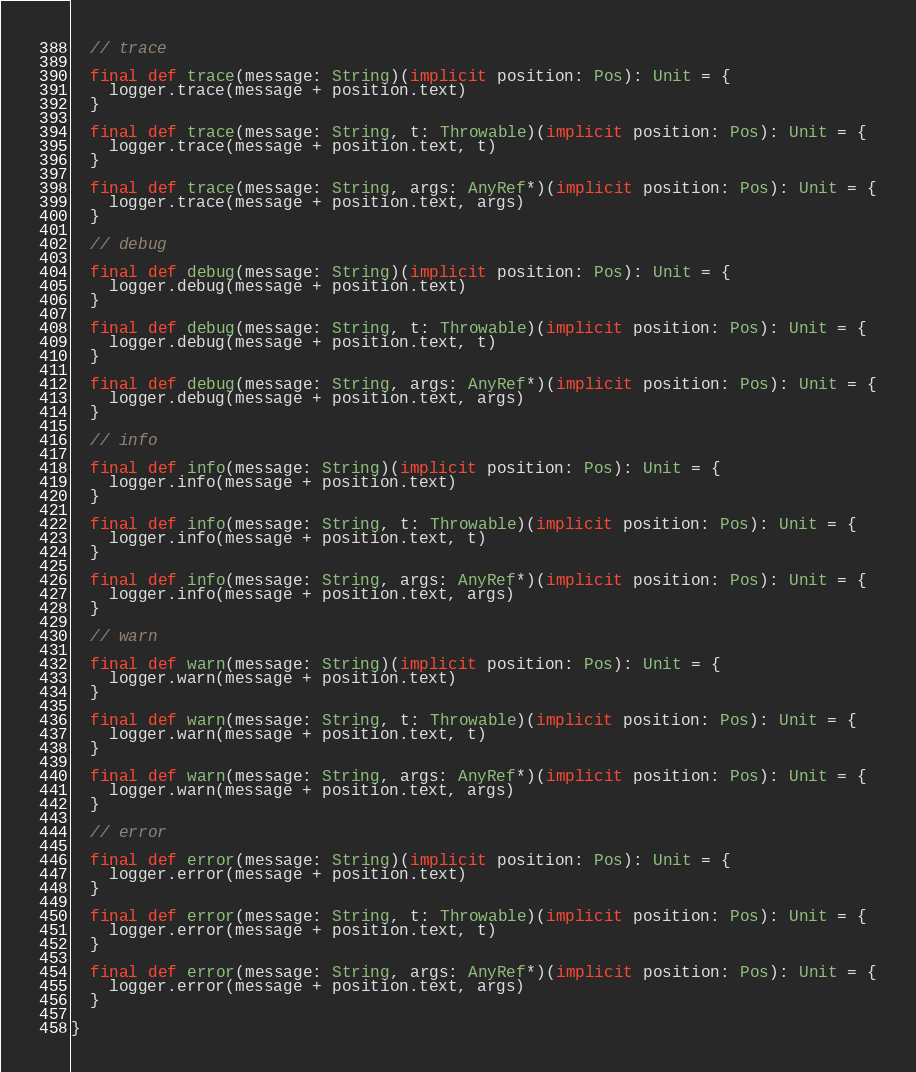<code> <loc_0><loc_0><loc_500><loc_500><_Scala_>  // trace

  final def trace(message: String)(implicit position: Pos): Unit = {
    logger.trace(message + position.text)
  }

  final def trace(message: String, t: Throwable)(implicit position: Pos): Unit = {
    logger.trace(message + position.text, t)
  }

  final def trace(message: String, args: AnyRef*)(implicit position: Pos): Unit = {
    logger.trace(message + position.text, args)
  }

  // debug

  final def debug(message: String)(implicit position: Pos): Unit = {
    logger.debug(message + position.text)
  }

  final def debug(message: String, t: Throwable)(implicit position: Pos): Unit = {
    logger.debug(message + position.text, t)
  }

  final def debug(message: String, args: AnyRef*)(implicit position: Pos): Unit = {
    logger.debug(message + position.text, args)
  }

  // info

  final def info(message: String)(implicit position: Pos): Unit = {
    logger.info(message + position.text)
  }

  final def info(message: String, t: Throwable)(implicit position: Pos): Unit = {
    logger.info(message + position.text, t)
  }

  final def info(message: String, args: AnyRef*)(implicit position: Pos): Unit = {
    logger.info(message + position.text, args)
  }

  // warn

  final def warn(message: String)(implicit position: Pos): Unit = {
    logger.warn(message + position.text)
  }

  final def warn(message: String, t: Throwable)(implicit position: Pos): Unit = {
    logger.warn(message + position.text, t)
  }

  final def warn(message: String, args: AnyRef*)(implicit position: Pos): Unit = {
    logger.warn(message + position.text, args)
  }

  // error

  final def error(message: String)(implicit position: Pos): Unit = {
    logger.error(message + position.text)
  }

  final def error(message: String, t: Throwable)(implicit position: Pos): Unit = {
    logger.error(message + position.text, t)
  }

  final def error(message: String, args: AnyRef*)(implicit position: Pos): Unit = {
    logger.error(message + position.text, args)
  }

}
</code> 